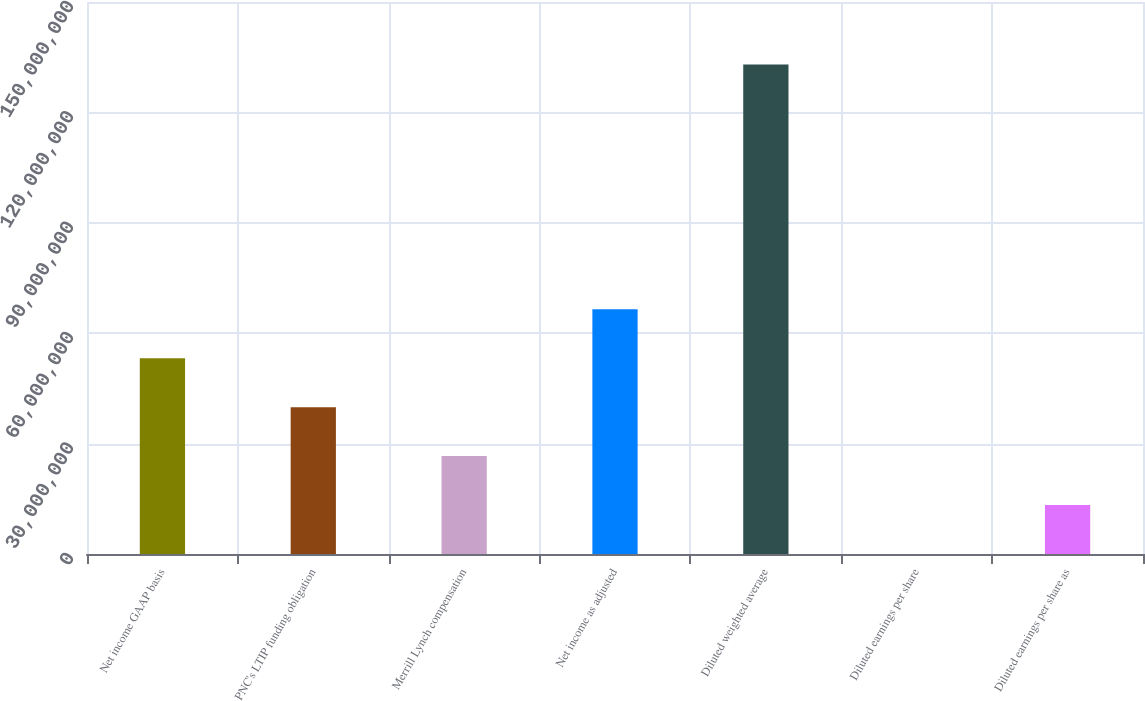Convert chart. <chart><loc_0><loc_0><loc_500><loc_500><bar_chart><fcel>Net income GAAP basis<fcel>PNC's LTIP funding obligation<fcel>Merrill Lynch compensation<fcel>Net income as adjusted<fcel>Diluted weighted average<fcel>Diluted earnings per share<fcel>Diluted earnings per share as<nl><fcel>5.31986e+07<fcel>3.98989e+07<fcel>2.65993e+07<fcel>6.64982e+07<fcel>1.32996e+08<fcel>5.91<fcel>1.32996e+07<nl></chart> 